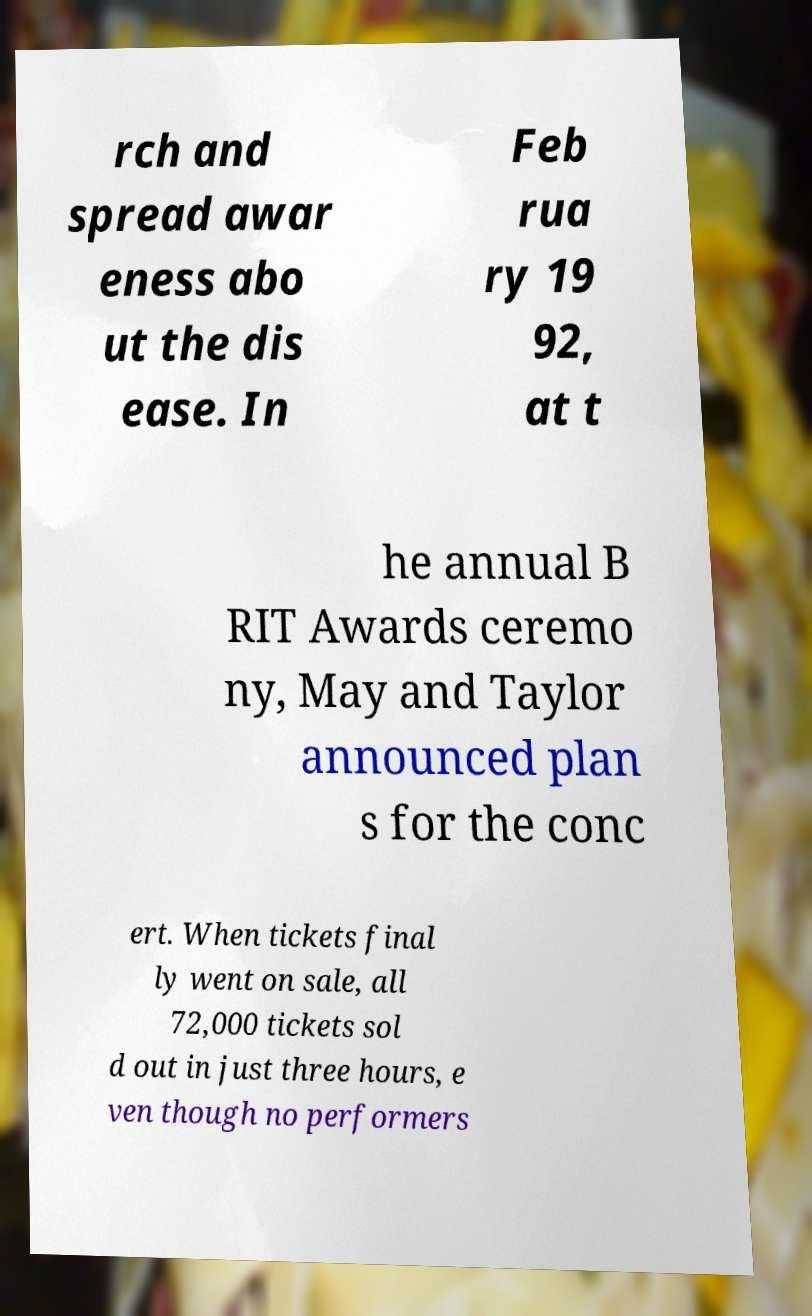Please read and relay the text visible in this image. What does it say? rch and spread awar eness abo ut the dis ease. In Feb rua ry 19 92, at t he annual B RIT Awards ceremo ny, May and Taylor announced plan s for the conc ert. When tickets final ly went on sale, all 72,000 tickets sol d out in just three hours, e ven though no performers 